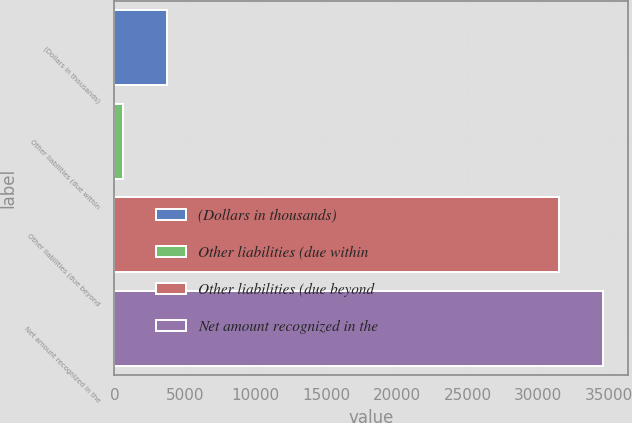Convert chart to OTSL. <chart><loc_0><loc_0><loc_500><loc_500><bar_chart><fcel>(Dollars in thousands)<fcel>Other liabilities (due within<fcel>Other liabilities (due beyond<fcel>Net amount recognized in the<nl><fcel>3759.7<fcel>614<fcel>31457<fcel>34602.7<nl></chart> 